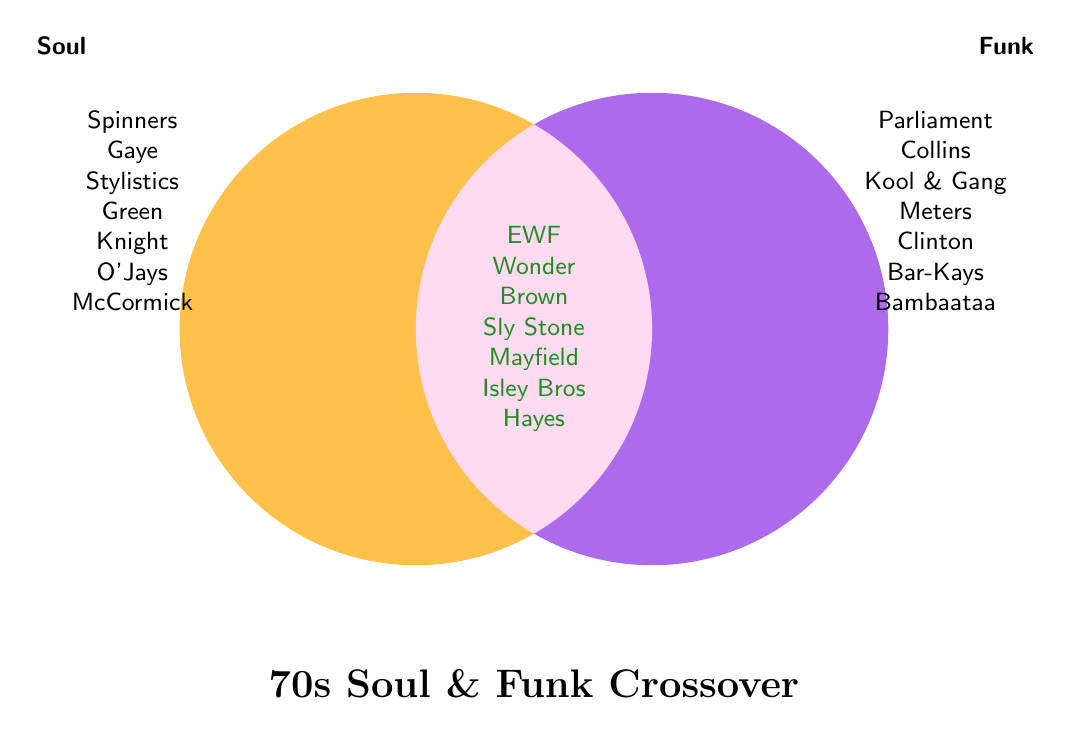Who is listed under both soul and funk? Identify the area where both Soul and Funk overlap, and list out the names: Earth Wind & Fire, Stevie Wonder, James Brown, Sly & The Family Stone, Curtis Mayfield, The Isley Brothers, Isaac Hayes
Answer: Earth Wind & Fire, Stevie Wonder, James Brown, Sly & The Family Stone, Curtis Mayfield, The Isley Brothers, Isaac Hayes Which artists are only associated with soul music? Check the section of the Venn Diagram solely representing Soul without overlap: The Spinners, Marvin Gaye, The Stylistics, Al Green, Gladys Knight, The O'Jays, Charles McCormick
Answer: The Spinners, Marvin Gaye, The Stylistics, Al Green, Gladys Knight, The O'Jays, Charles McCormick Which artists are only associated with funk music? Look at the section of the Venn Diagram solely representing Funk without overlap: Parliament, Bootsy Collins, Kool & the Gang, The Meters, George Clinton, The Bar-Kays, Afrika Bambaataa
Answer: Parliament, Bootsy Collins, Kool & the Gang, The Meters, George Clinton, The Bar-Kays, Afrika Bambaataa How many artists are in both soul and funk categories? Count the names listed in the overlapping section of the Venn Diagram: Earth Wind & Fire, Stevie Wonder, James Brown, Sly & The Family Stone, Curtis Mayfield, The Isley Brothers, Isaac Hayes. Total count is 7
Answer: 7 Are there any artists in both categories named The Meters? Look at the overlapping section to check if The Meters are listed there; they are only in the Funk section. Thus, they are not in both categories.
Answer: No Which category does Charles McCormick belong to? Find Charles McCormick’s name in the Venn Diagram; it is listed under Soul.
Answer: Soul Is Stevie Wonder associated with only soul, only funk, or both? Check the overlap section where Stevie Wonder is placed, indicating association with both Soul and Funk.
Answer: Both Name the artists in the group with the least number of artists. Compare the number of artists in each segment: Soul has 7, Funk has 7, Both have 7. Since all groups have an equal number, there isn’t one with the least.
Answer: All groups have equal numbers Are The Isley Brothers only associated with one genre or both? The Isley Brothers are listed in the overlapping section, meaning they are associated with both Soul and Funk.
Answer: Both 